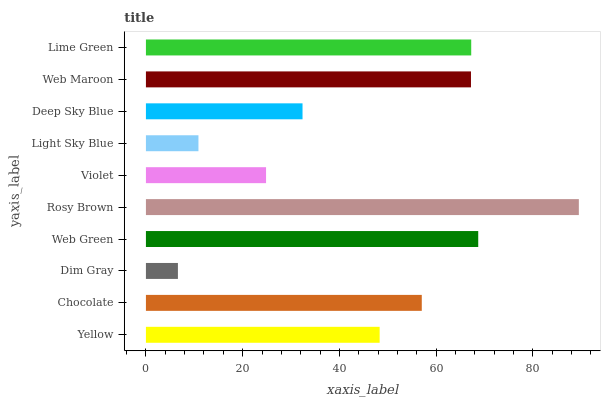Is Dim Gray the minimum?
Answer yes or no. Yes. Is Rosy Brown the maximum?
Answer yes or no. Yes. Is Chocolate the minimum?
Answer yes or no. No. Is Chocolate the maximum?
Answer yes or no. No. Is Chocolate greater than Yellow?
Answer yes or no. Yes. Is Yellow less than Chocolate?
Answer yes or no. Yes. Is Yellow greater than Chocolate?
Answer yes or no. No. Is Chocolate less than Yellow?
Answer yes or no. No. Is Chocolate the high median?
Answer yes or no. Yes. Is Yellow the low median?
Answer yes or no. Yes. Is Violet the high median?
Answer yes or no. No. Is Rosy Brown the low median?
Answer yes or no. No. 